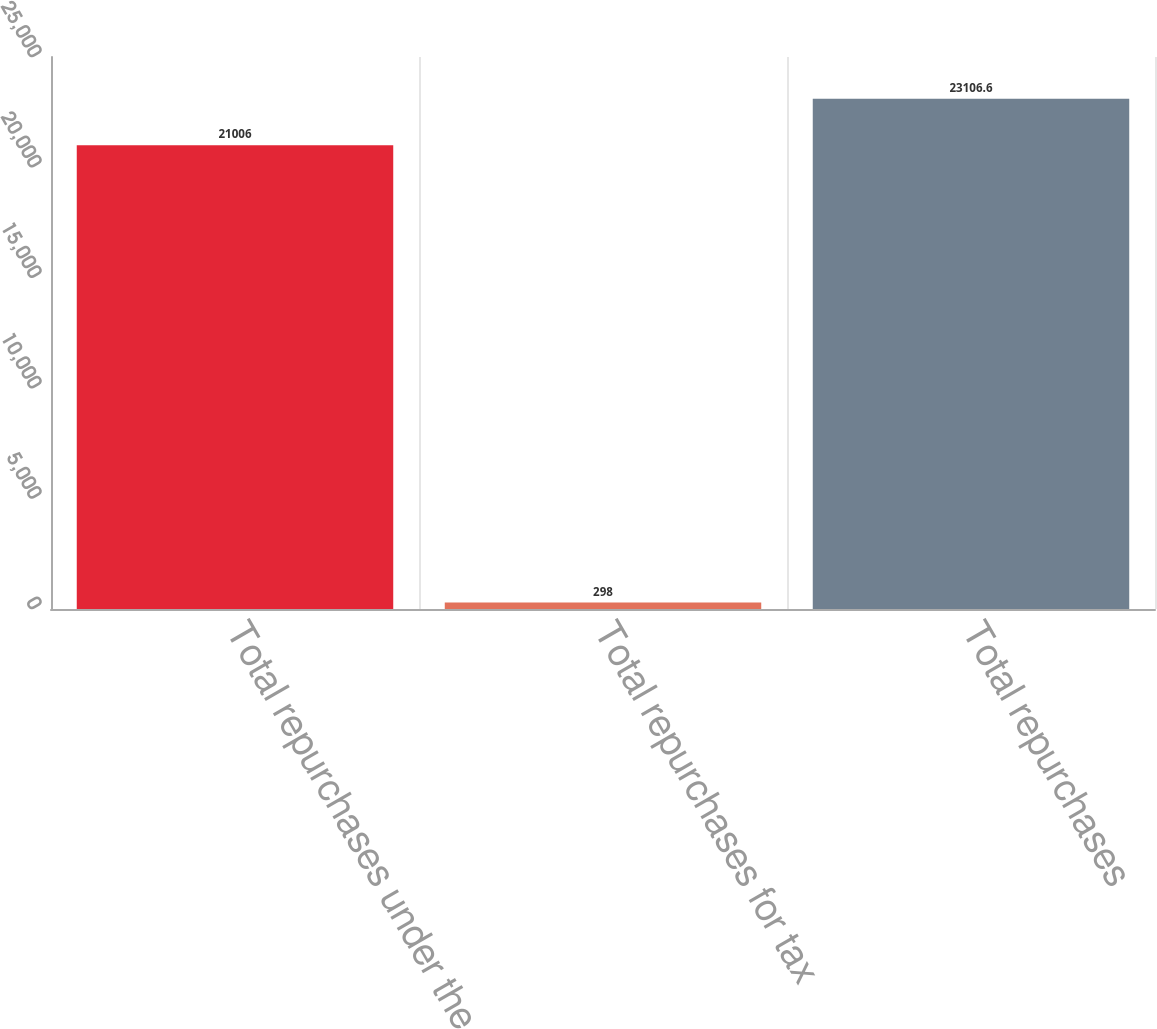Convert chart to OTSL. <chart><loc_0><loc_0><loc_500><loc_500><bar_chart><fcel>Total repurchases under the<fcel>Total repurchases for tax<fcel>Total repurchases<nl><fcel>21006<fcel>298<fcel>23106.6<nl></chart> 